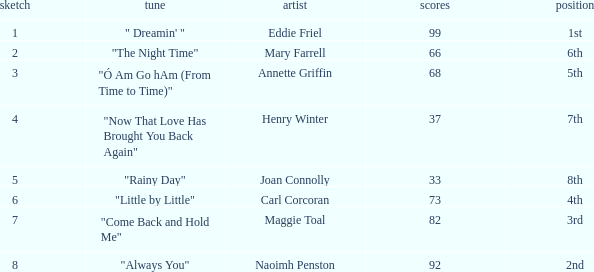Which song has more than 66 points, a draw greater than 3, and is ranked 3rd? "Come Back and Hold Me". 